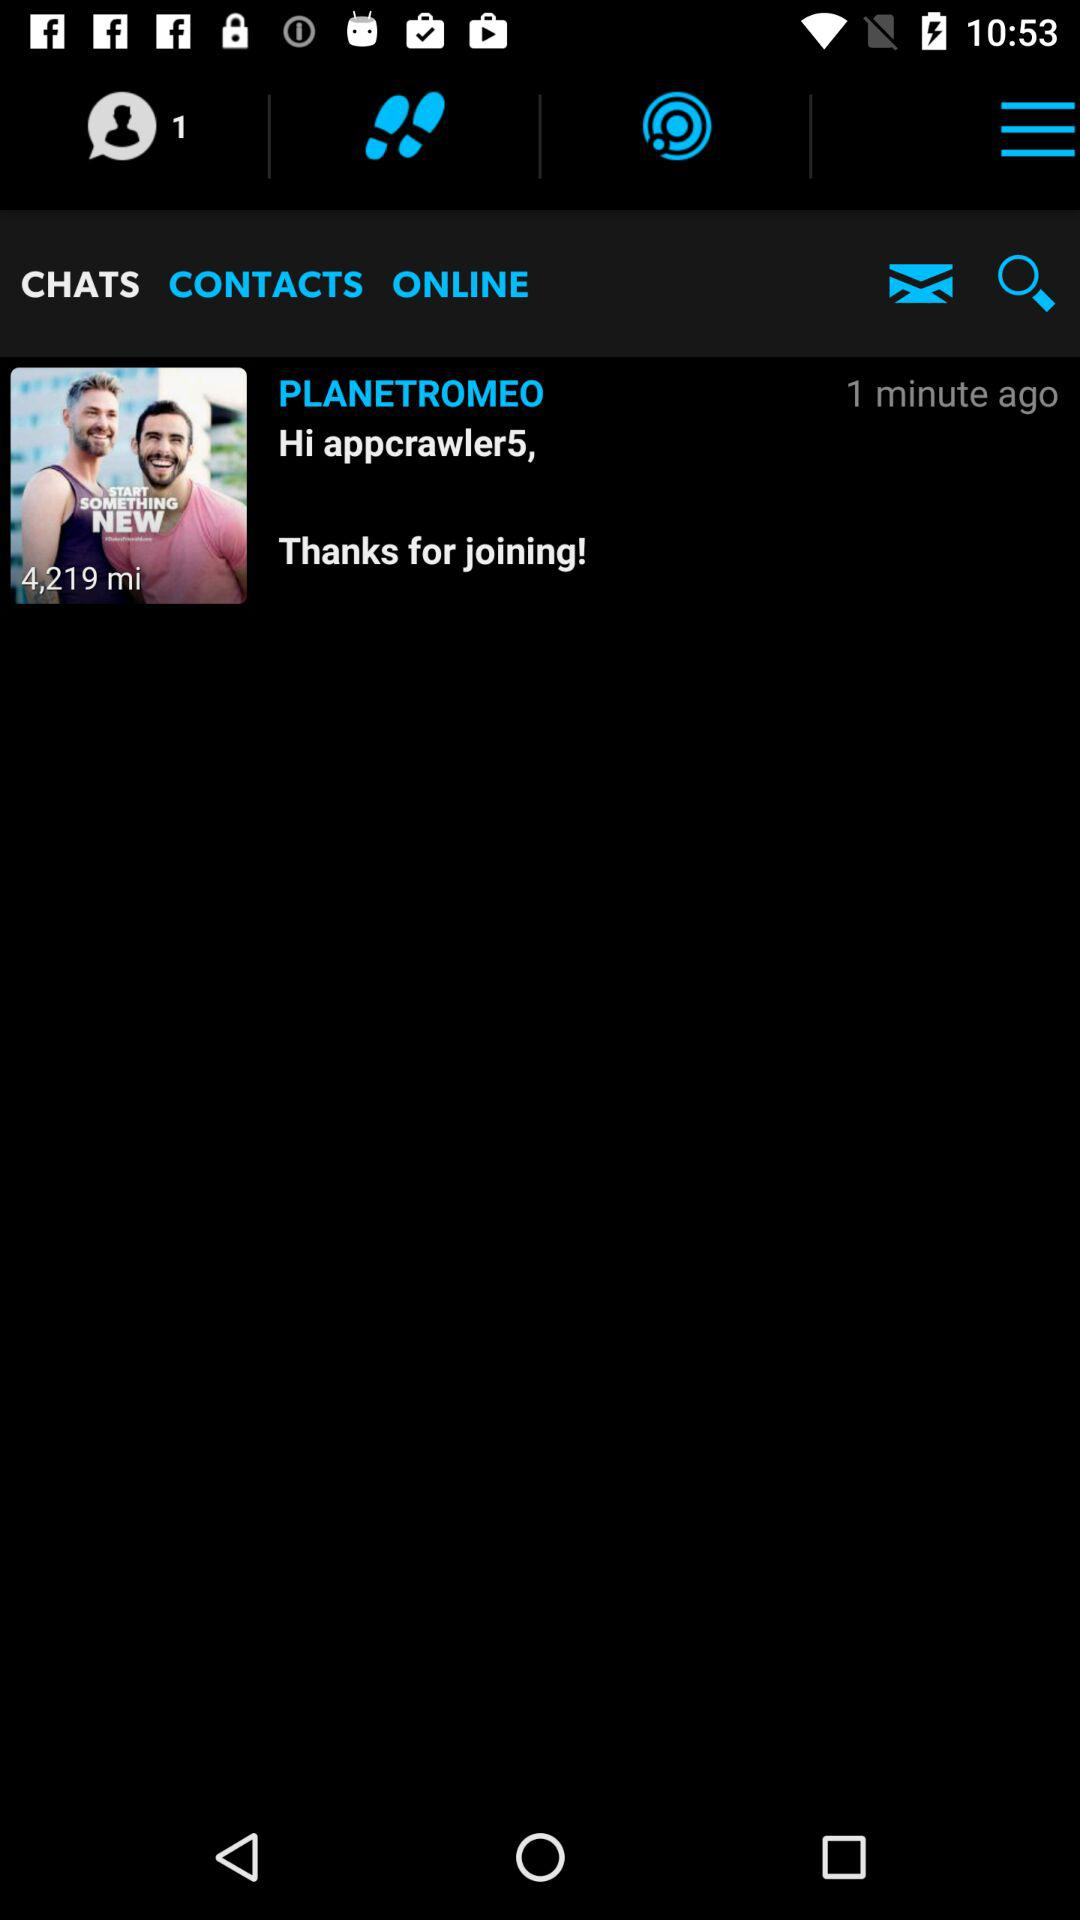What is the displayed username? The displayed username is "appcrawler5". 